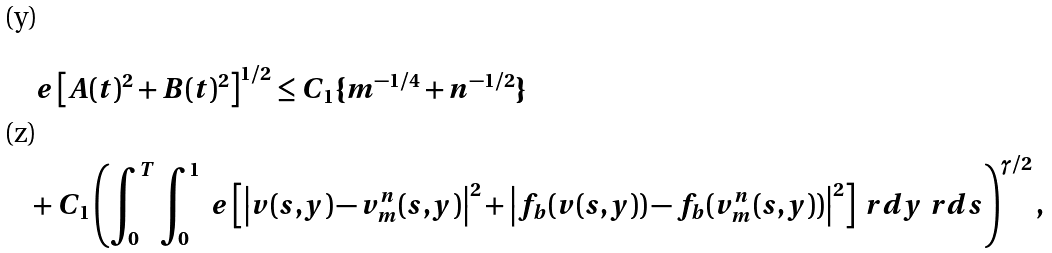<formula> <loc_0><loc_0><loc_500><loc_500>& \ e \left [ A ( t ) ^ { 2 } + B ( t ) ^ { 2 } \right ] ^ { 1 / 2 } \leq C _ { 1 } \{ m ^ { - 1 / 4 } + n ^ { - 1 / 2 } \} \\ & + C _ { 1 } \left ( \int _ { 0 } ^ { T } \int _ { 0 } ^ { 1 } \ e \left [ \left | v ( s , y ) - v _ { m } ^ { n } ( s , y ) \right | ^ { 2 } + \left | f _ { b } ( v ( s , y ) ) - f _ { b } ( v _ { m } ^ { n } ( s , y ) ) \right | ^ { 2 } \right ] \ r d y \ r d s \right ) ^ { \gamma / 2 } ,</formula> 